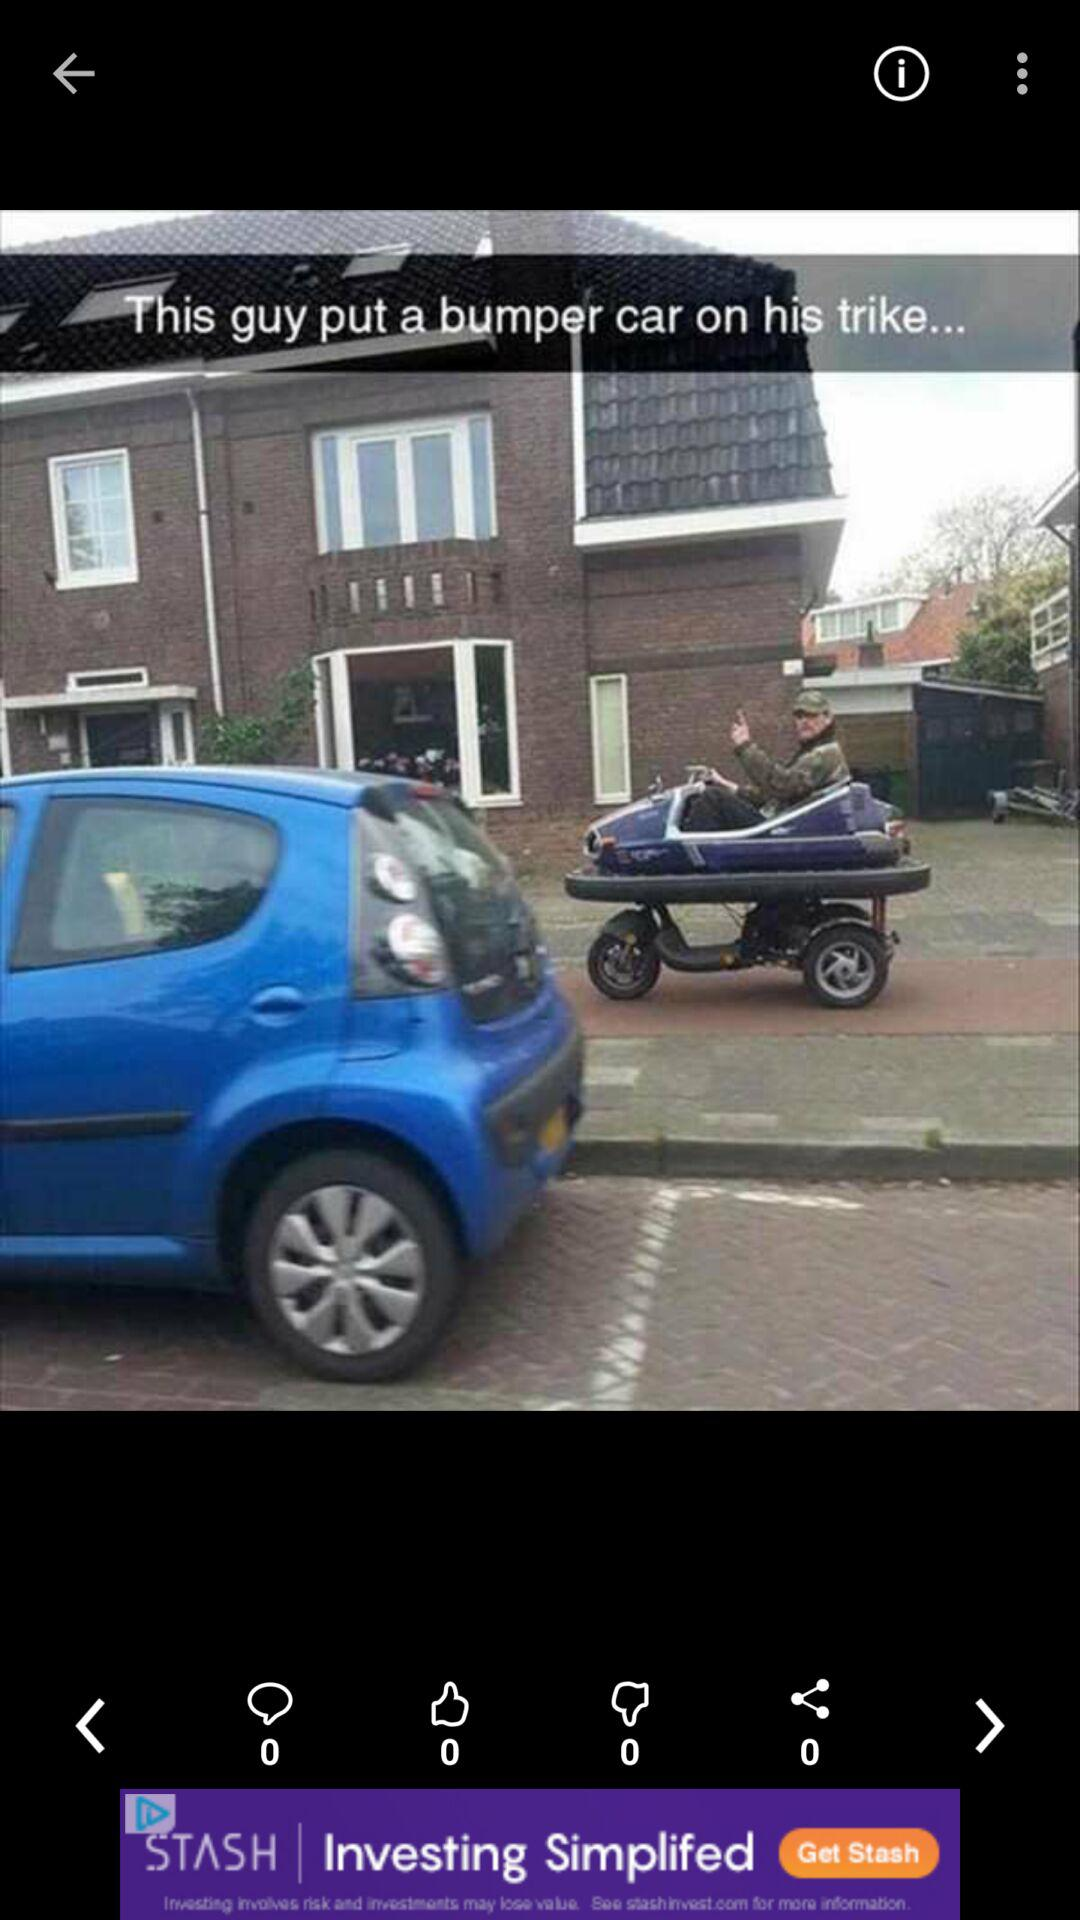How many comments are there on the post? There are 0 comments. 